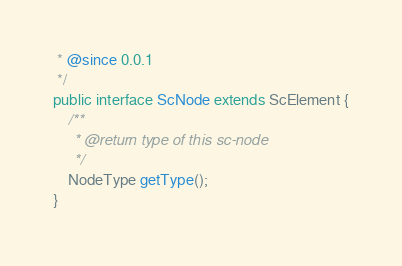Convert code to text. <code><loc_0><loc_0><loc_500><loc_500><_Java_> * @since 0.0.1
 */
public interface ScNode extends ScElement {
    /**
     * @return type of this sc-node
     */
    NodeType getType();
}
</code> 